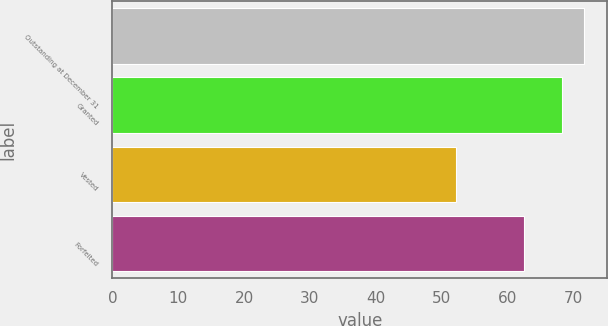<chart> <loc_0><loc_0><loc_500><loc_500><bar_chart><fcel>Outstanding at December 31<fcel>Granted<fcel>Vested<fcel>Forfeited<nl><fcel>71.59<fcel>68.33<fcel>52.26<fcel>62.5<nl></chart> 